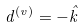Convert formula to latex. <formula><loc_0><loc_0><loc_500><loc_500>d ^ { ( v ) } = - \hat { k }</formula> 